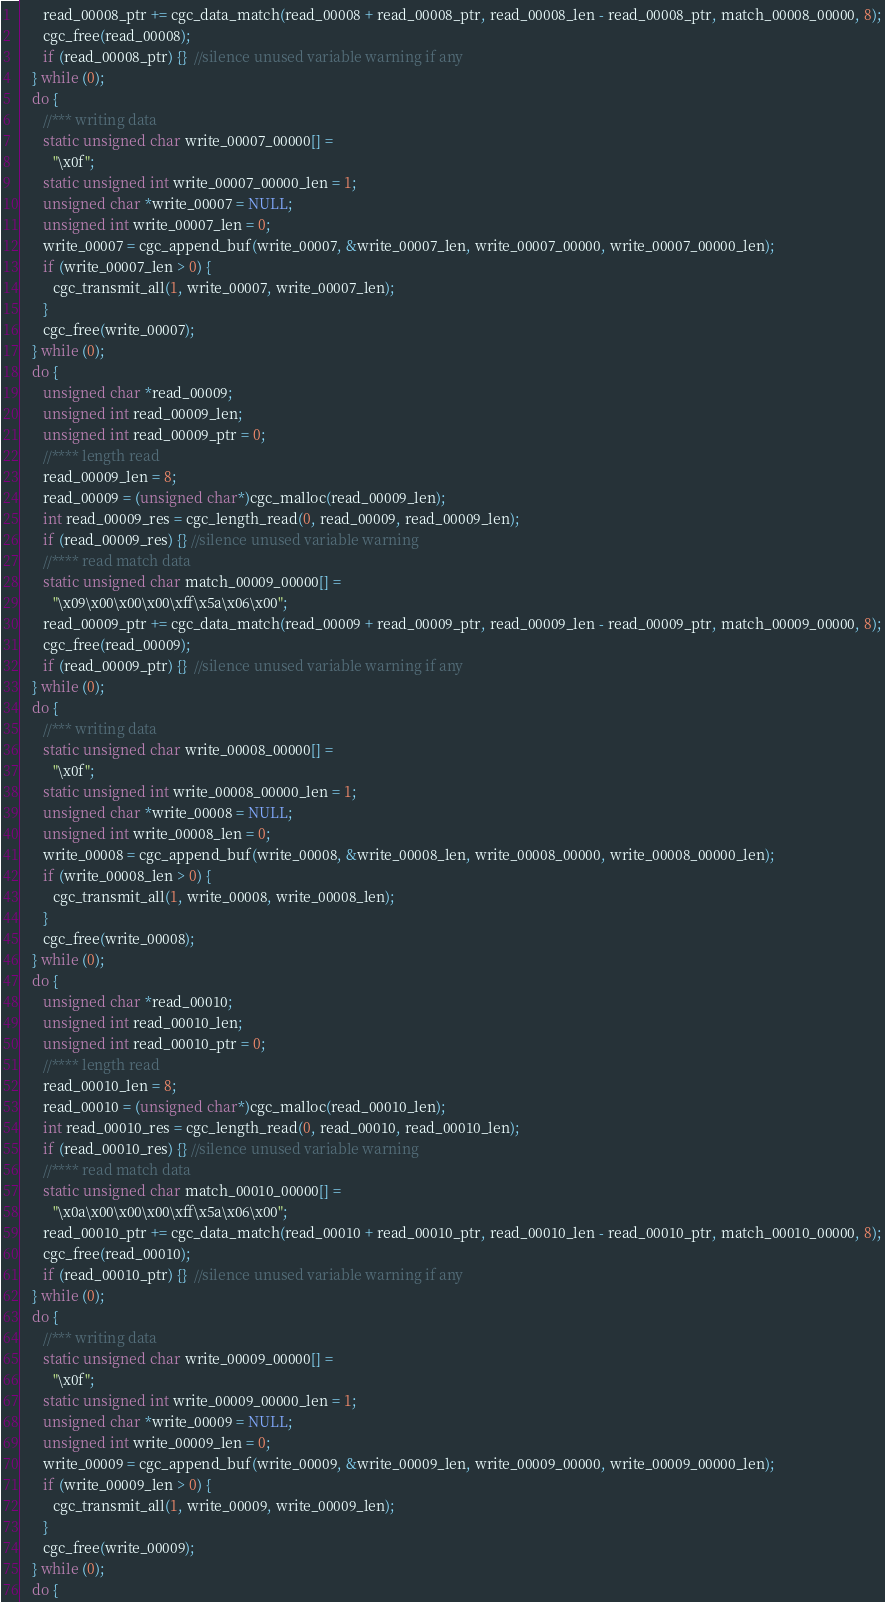<code> <loc_0><loc_0><loc_500><loc_500><_C_>      read_00008_ptr += cgc_data_match(read_00008 + read_00008_ptr, read_00008_len - read_00008_ptr, match_00008_00000, 8);
      cgc_free(read_00008);
      if (read_00008_ptr) {}  //silence unused variable warning if any
   } while (0);
   do {
      //*** writing data
      static unsigned char write_00007_00000[] = 
         "\x0f";
      static unsigned int write_00007_00000_len = 1;
      unsigned char *write_00007 = NULL;
      unsigned int write_00007_len = 0;
      write_00007 = cgc_append_buf(write_00007, &write_00007_len, write_00007_00000, write_00007_00000_len);
      if (write_00007_len > 0) {
         cgc_transmit_all(1, write_00007, write_00007_len);
      }
      cgc_free(write_00007);
   } while (0);
   do {
      unsigned char *read_00009;
      unsigned int read_00009_len;
      unsigned int read_00009_ptr = 0;
      //**** length read
      read_00009_len = 8;
      read_00009 = (unsigned char*)cgc_malloc(read_00009_len);
      int read_00009_res = cgc_length_read(0, read_00009, read_00009_len);
      if (read_00009_res) {} //silence unused variable warning
      //**** read match data
      static unsigned char match_00009_00000[] = 
         "\x09\x00\x00\x00\xff\x5a\x06\x00";
      read_00009_ptr += cgc_data_match(read_00009 + read_00009_ptr, read_00009_len - read_00009_ptr, match_00009_00000, 8);
      cgc_free(read_00009);
      if (read_00009_ptr) {}  //silence unused variable warning if any
   } while (0);
   do {
      //*** writing data
      static unsigned char write_00008_00000[] = 
         "\x0f";
      static unsigned int write_00008_00000_len = 1;
      unsigned char *write_00008 = NULL;
      unsigned int write_00008_len = 0;
      write_00008 = cgc_append_buf(write_00008, &write_00008_len, write_00008_00000, write_00008_00000_len);
      if (write_00008_len > 0) {
         cgc_transmit_all(1, write_00008, write_00008_len);
      }
      cgc_free(write_00008);
   } while (0);
   do {
      unsigned char *read_00010;
      unsigned int read_00010_len;
      unsigned int read_00010_ptr = 0;
      //**** length read
      read_00010_len = 8;
      read_00010 = (unsigned char*)cgc_malloc(read_00010_len);
      int read_00010_res = cgc_length_read(0, read_00010, read_00010_len);
      if (read_00010_res) {} //silence unused variable warning
      //**** read match data
      static unsigned char match_00010_00000[] = 
         "\x0a\x00\x00\x00\xff\x5a\x06\x00";
      read_00010_ptr += cgc_data_match(read_00010 + read_00010_ptr, read_00010_len - read_00010_ptr, match_00010_00000, 8);
      cgc_free(read_00010);
      if (read_00010_ptr) {}  //silence unused variable warning if any
   } while (0);
   do {
      //*** writing data
      static unsigned char write_00009_00000[] = 
         "\x0f";
      static unsigned int write_00009_00000_len = 1;
      unsigned char *write_00009 = NULL;
      unsigned int write_00009_len = 0;
      write_00009 = cgc_append_buf(write_00009, &write_00009_len, write_00009_00000, write_00009_00000_len);
      if (write_00009_len > 0) {
         cgc_transmit_all(1, write_00009, write_00009_len);
      }
      cgc_free(write_00009);
   } while (0);
   do {</code> 